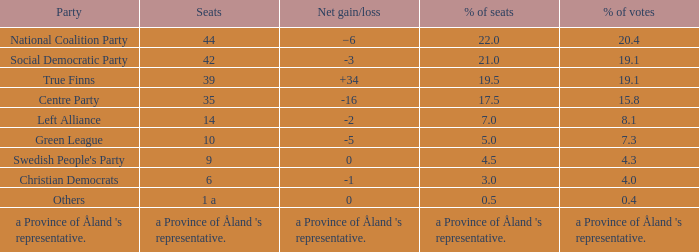When the Swedish People's Party had a net gain/loss of 0, how many seats did they have? 9.0. 